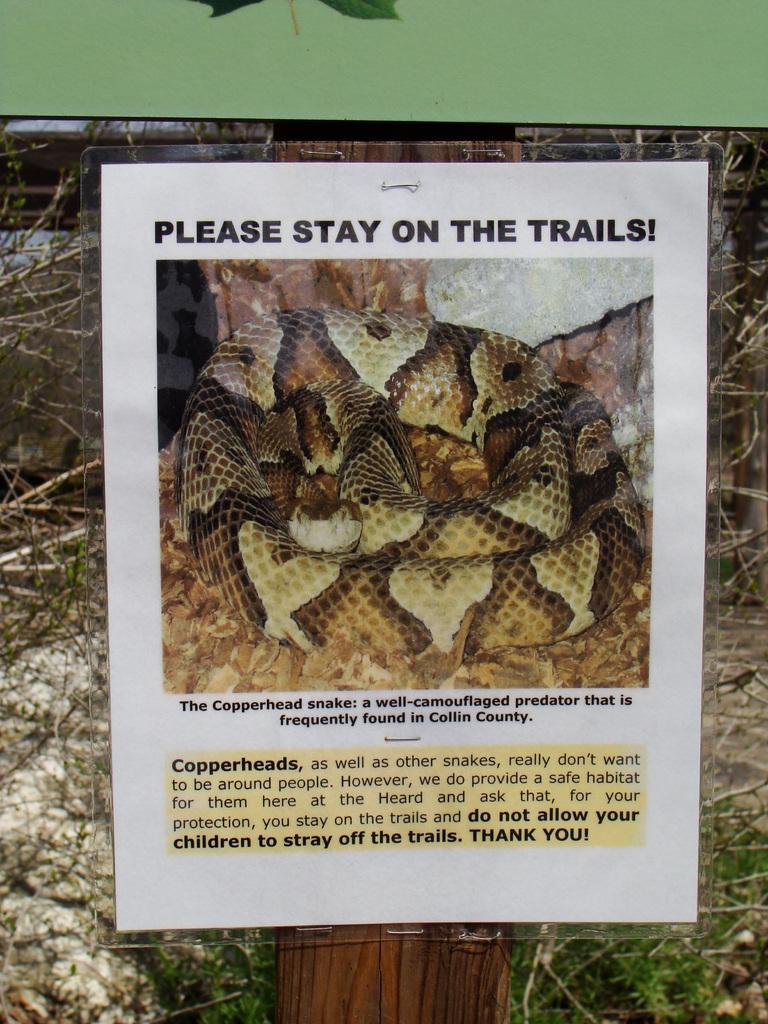In one or two sentences, can you explain what this image depicts? In this image, we can see a photo, in that photo, we can see a snake and some text. 